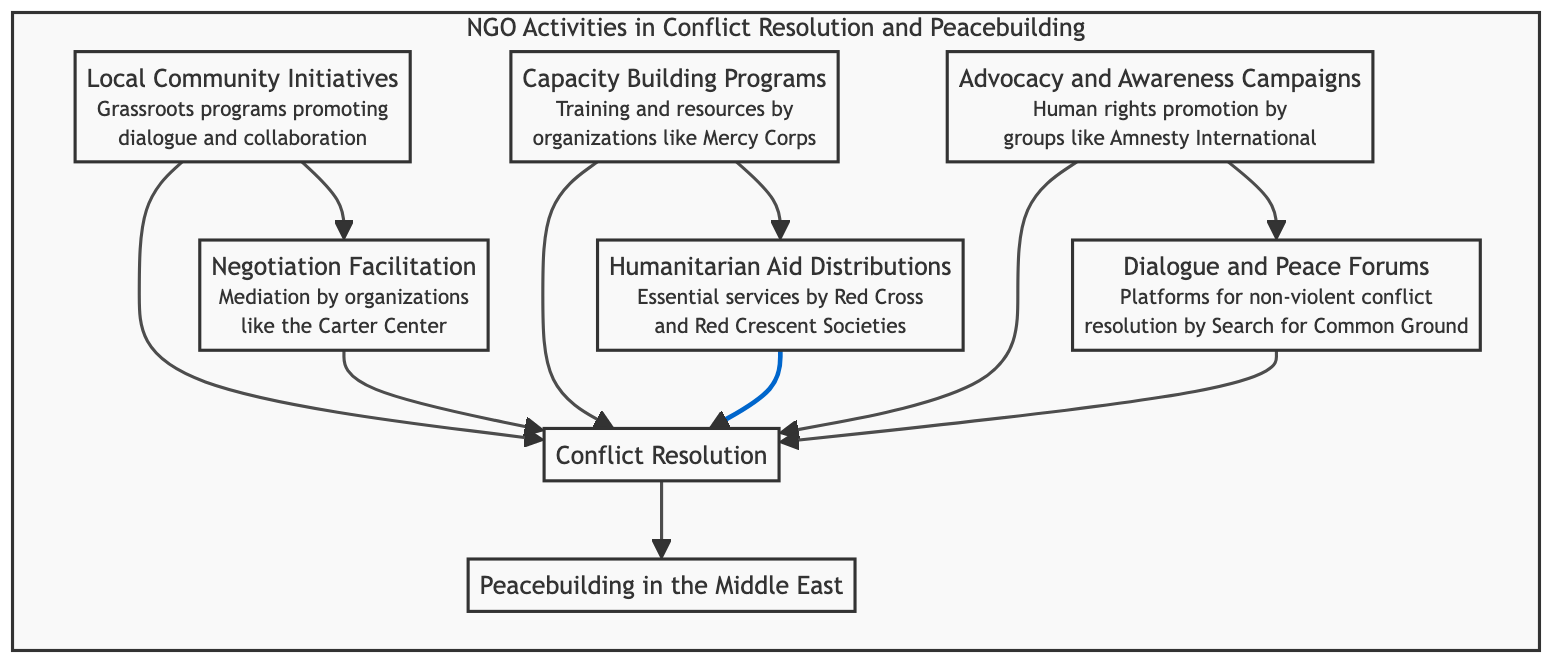What are the two types of initiatives represented at the top level of the flowchart? The flowchart shows "Local Community Initiatives" and "Negotiation Facilitation" as the two top-level activities. They are connected to the common outcome of "Conflict Resolution."
Answer: Local Community Initiatives and Negotiation Facilitation How many types of NGO activities contribute to "Conflict Resolution"? The diagram illustrates five distinct activities that directly lead to "Conflict Resolution." These are Local Community Initiatives, Negotiation Facilitation, Capacity Building Programs, Humanitarian Aid Distributions, Advocacy and Awareness Campaigns, and Dialogue and Peace Forums.
Answer: Five What is the final goal of all the NGO activities illustrated in the flowchart? All the activities illustrated contribute to the ultimate goal which is "Peacebuilding in the Middle East." Hence, every pathway leads toward this common objective.
Answer: Peacebuilding in the Middle East Which organization is mentioned in connection with "Negotiation Facilitation"? The "Negotiation Facilitation" activity in the flowchart specifies the Carter Center as an organization that mediates discussions between conflicting parties.
Answer: Carter Center What is the purpose of "Capacity Building Programs"? The description linked to "Capacity Building Programs" indicates that they are aimed at empowering local leaders and communities in conflict zones through training and resources provided by organizations like Mercy Corps.
Answer: Empowering local leaders and communities Which two activities are related to humanitarian efforts in the diagram? The activities related to humanitarian efforts present in the diagram are "Humanitarian Aid Distributions" and "Conflict Resolution." Both highlight the emphasis on providing essential services and responding to conflict needs.
Answer: Humanitarian Aid Distributions and Conflict Resolution What types of campaigns does "Advocacy and Awareness Campaigns" include? The activity "Advocacy and Awareness Campaigns" focuses on initiatives that promote human rights and accountability, as indicated in the description of this node.
Answer: Human rights and accountability campaigns How do Local Community Initiatives and Advocacy and Awareness Campaigns contribute to the peacebuilding process? Both "Local Community Initiatives" and "Advocacy and Awareness Campaigns" feed into the central node "Conflict Resolution," highlighting their role in fostering dialogue and promoting accountability, respectively, which are crucial for the peacebuilding process.
Answer: They foster dialogue and promote accountability What node connects all the NGO activities to the final outcome? The node labeled "Conflict Resolution" serves as the connecting point for all the NGO activities leading toward the ultimate aim of "Peacebuilding in the Middle East." Each activity routes through this node before achieving peacebuilding.
Answer: Conflict Resolution 